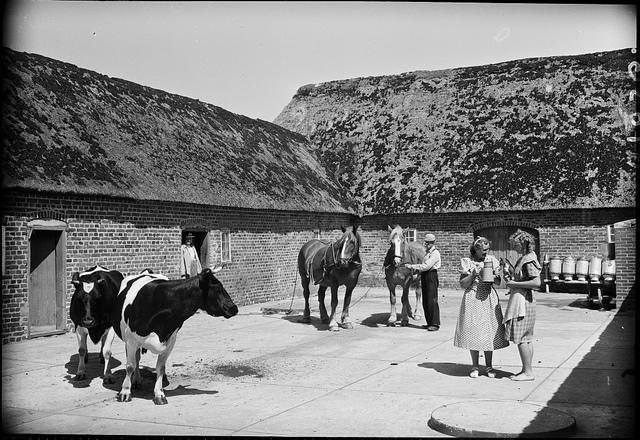How many horses are there?
Give a very brief answer. 2. How many cows are brown?
Give a very brief answer. 0. How many horses are in the photo?
Give a very brief answer. 2. How many cows are in the picture?
Give a very brief answer. 2. How many people are there?
Give a very brief answer. 2. 